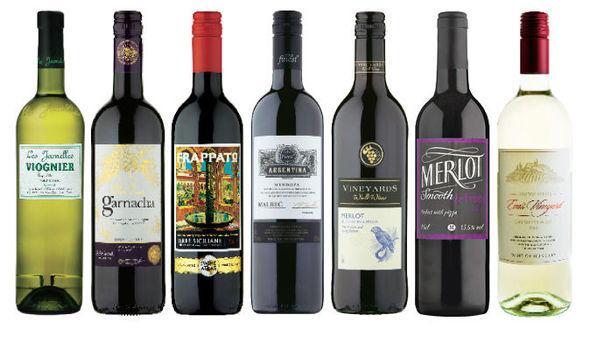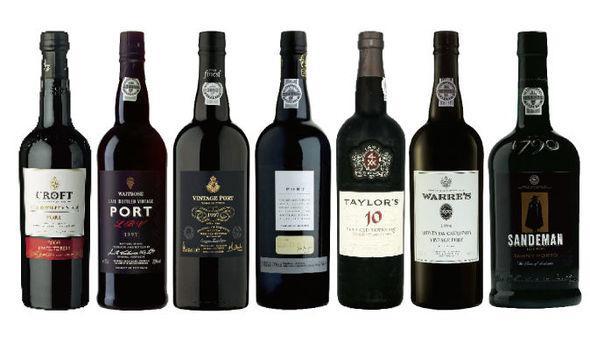The first image is the image on the left, the second image is the image on the right. For the images shown, is this caption "Seven different unopened bottles of wine are lined up in each image." true? Answer yes or no. Yes. 